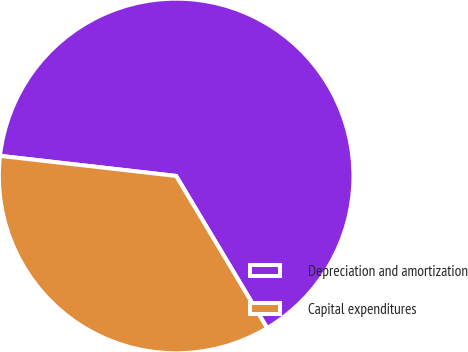<chart> <loc_0><loc_0><loc_500><loc_500><pie_chart><fcel>Depreciation and amortization<fcel>Capital expenditures<nl><fcel>64.61%<fcel>35.39%<nl></chart> 